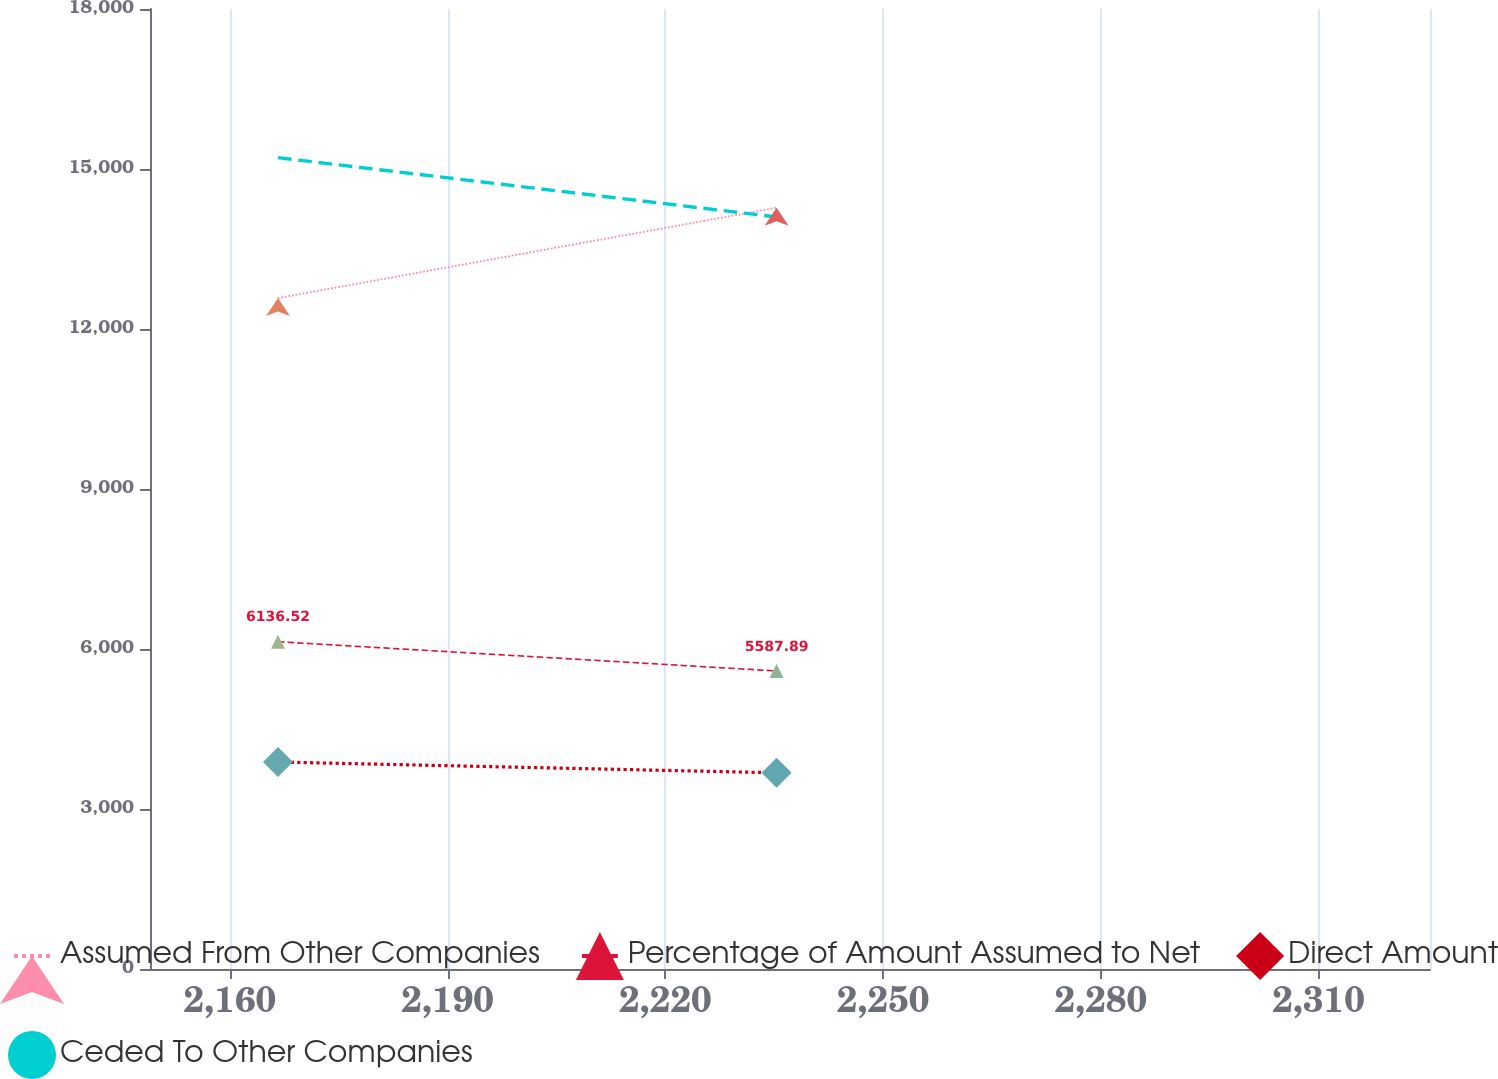Convert chart to OTSL. <chart><loc_0><loc_0><loc_500><loc_500><line_chart><ecel><fcel>Assumed From Other Companies<fcel>Percentage of Amount Assumed to Net<fcel>Direct Amount<fcel>Ceded To Other Companies<nl><fcel>2166.62<fcel>12580<fcel>6136.52<fcel>3880.74<fcel>15212.6<nl><fcel>2235.32<fcel>14273.8<fcel>5587.89<fcel>3678.69<fcel>14100.8<nl><fcel>2342.99<fcel>14795.7<fcel>6846.84<fcel>3054.68<fcel>10606.8<nl></chart> 